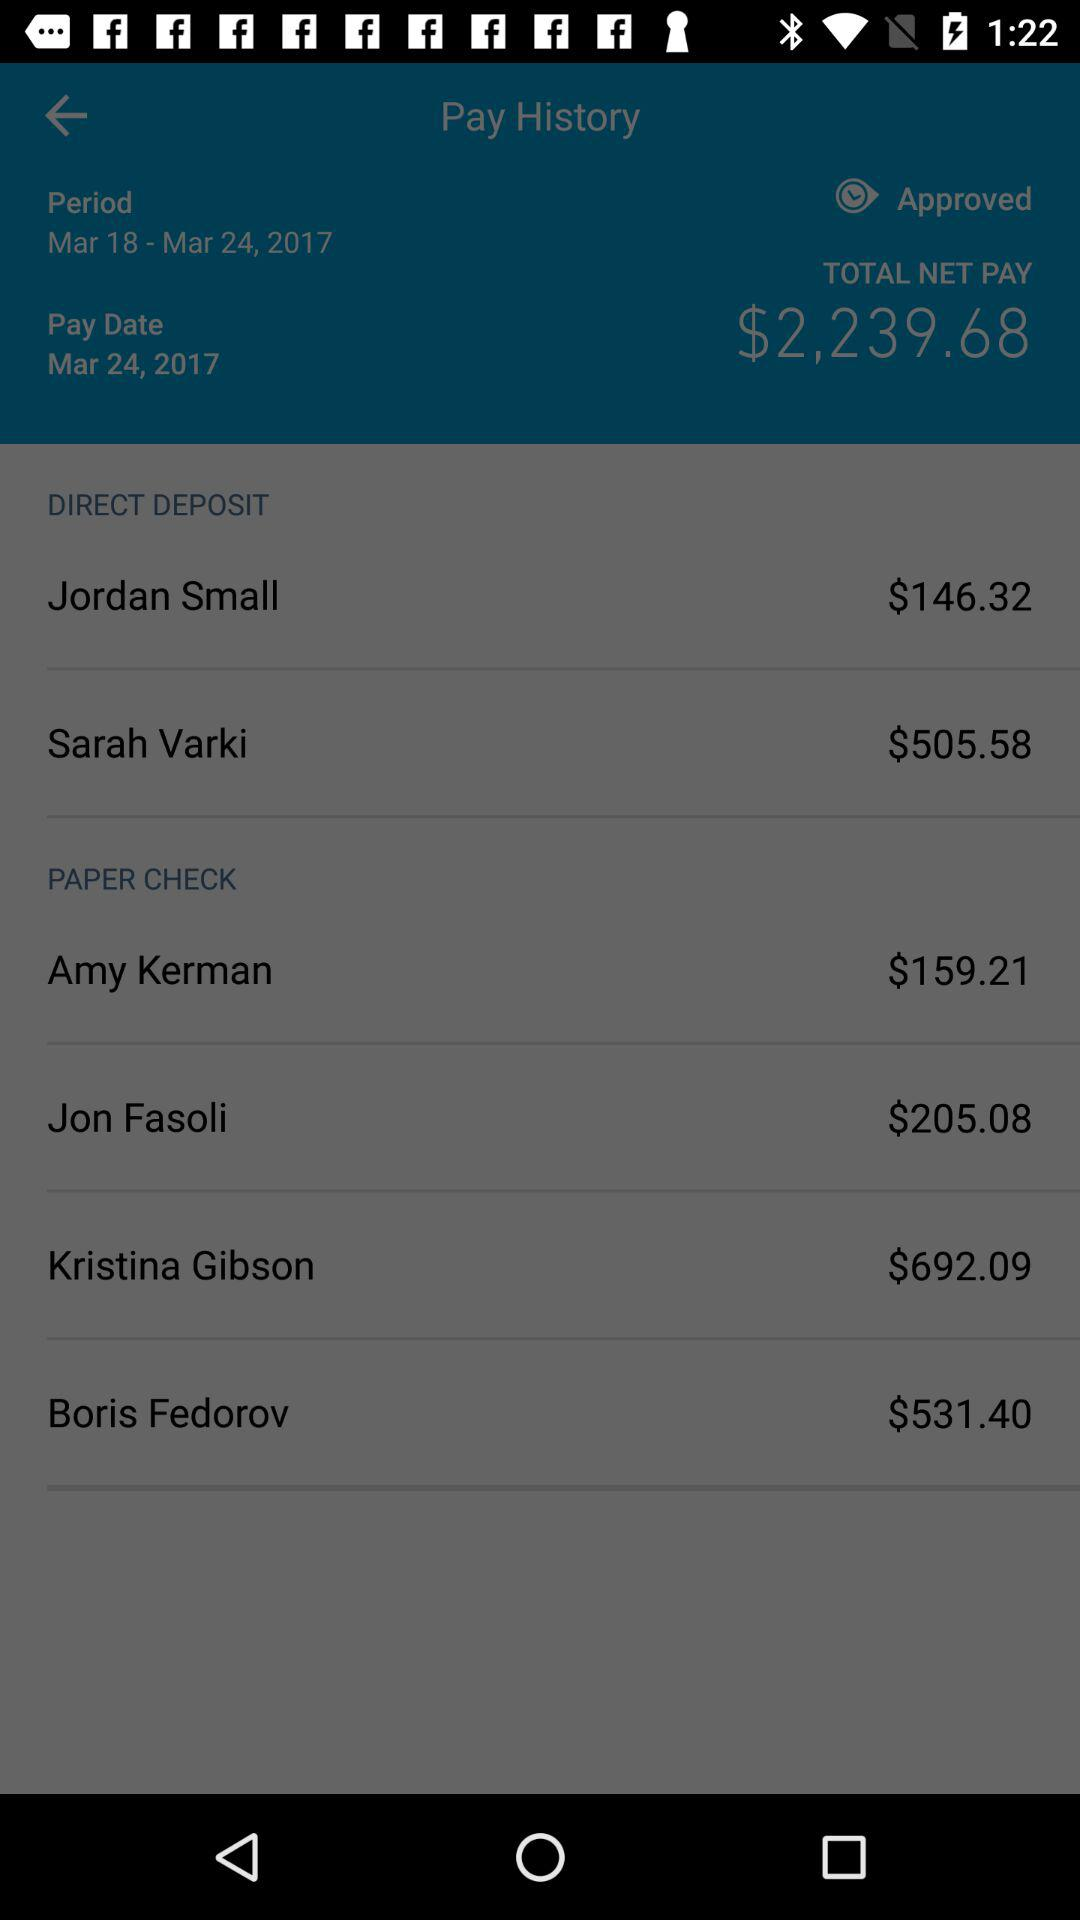What is the period? The period is from March 18 to March 24, 2017. 